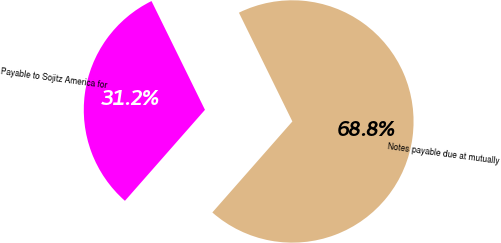Convert chart to OTSL. <chart><loc_0><loc_0><loc_500><loc_500><pie_chart><fcel>Notes payable due at mutually<fcel>Payable to Sojitz America for<nl><fcel>68.75%<fcel>31.25%<nl></chart> 